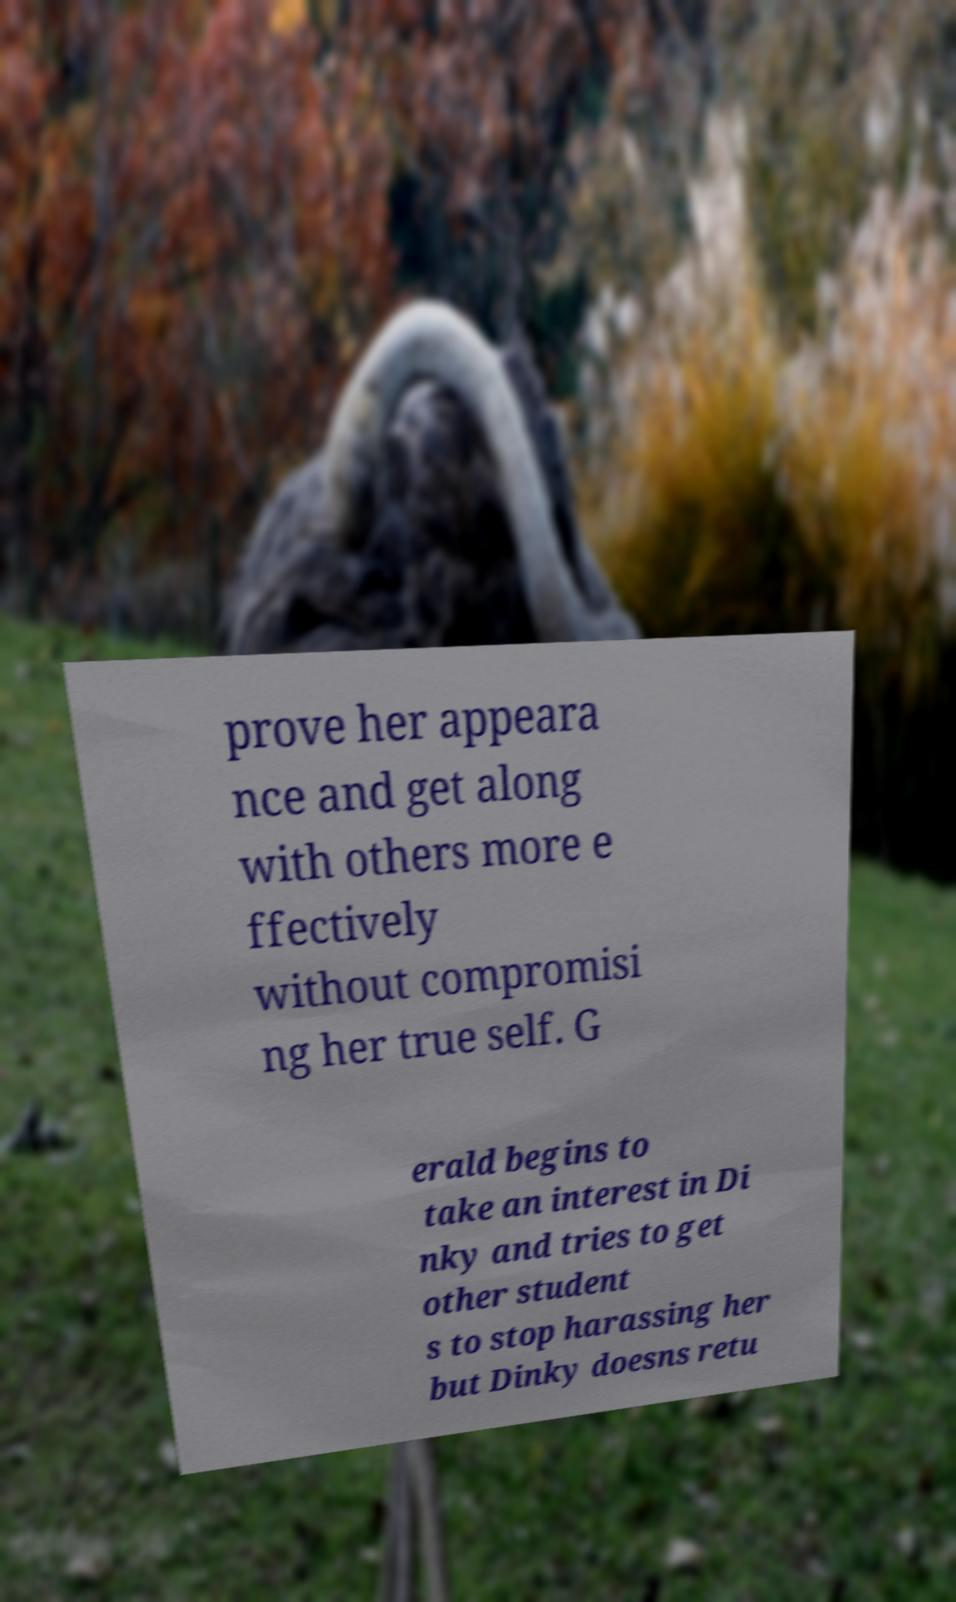Can you read and provide the text displayed in the image?This photo seems to have some interesting text. Can you extract and type it out for me? prove her appeara nce and get along with others more e ffectively without compromisi ng her true self. G erald begins to take an interest in Di nky and tries to get other student s to stop harassing her but Dinky doesns retu 